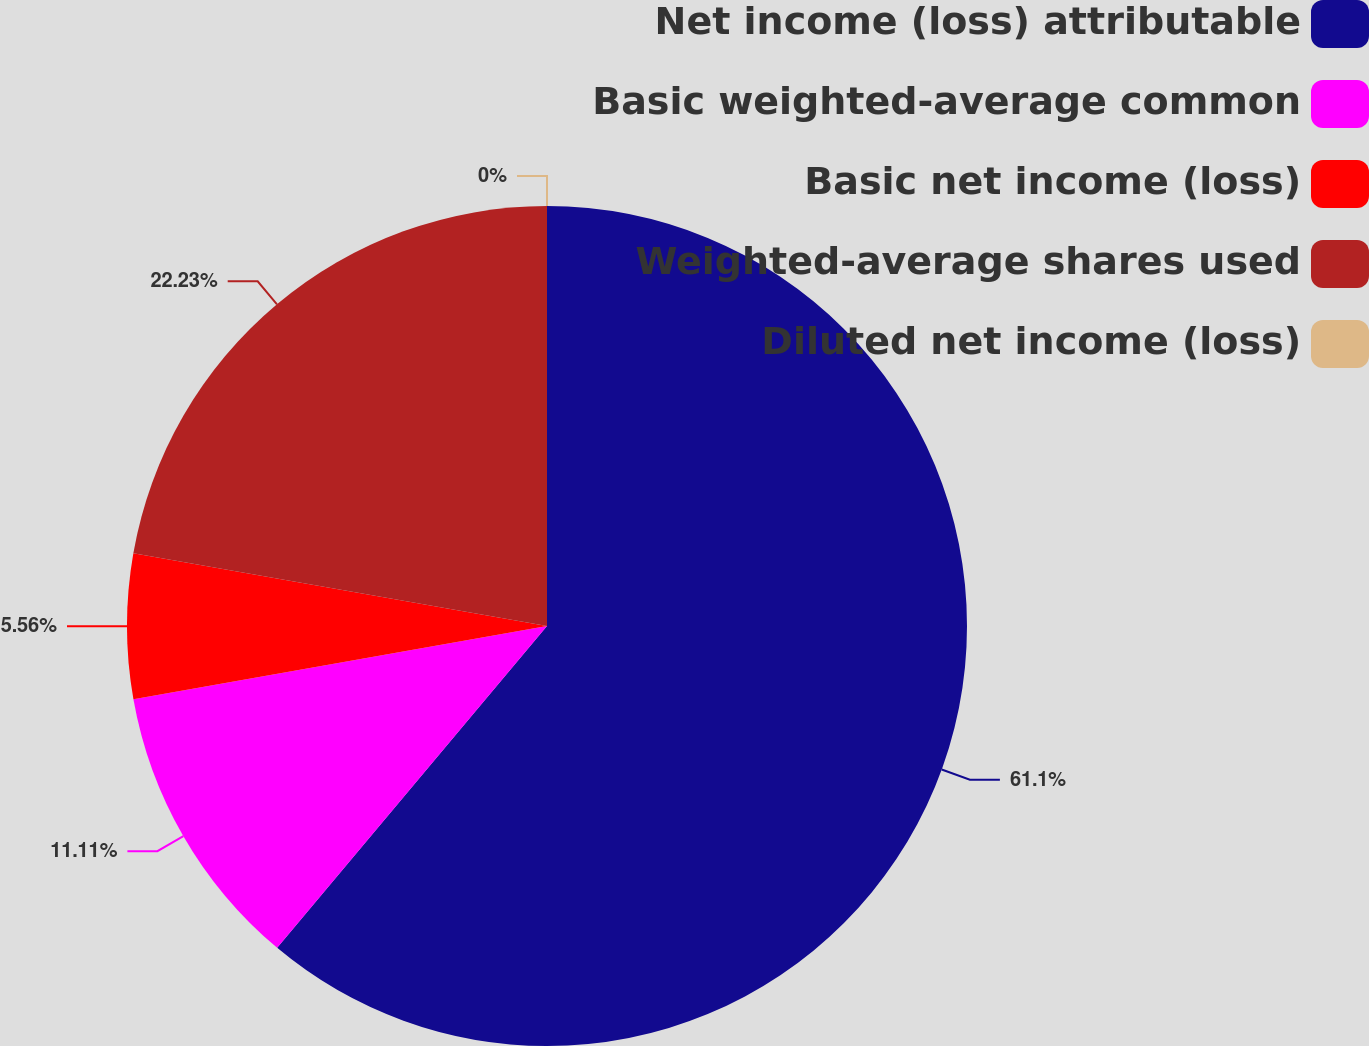<chart> <loc_0><loc_0><loc_500><loc_500><pie_chart><fcel>Net income (loss) attributable<fcel>Basic weighted-average common<fcel>Basic net income (loss)<fcel>Weighted-average shares used<fcel>Diluted net income (loss)<nl><fcel>61.11%<fcel>11.11%<fcel>5.56%<fcel>22.23%<fcel>0.0%<nl></chart> 